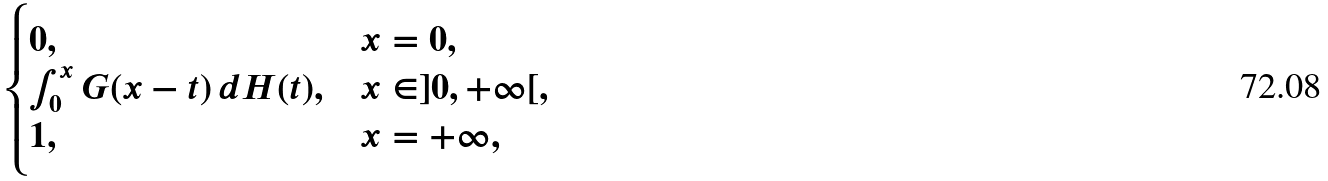<formula> <loc_0><loc_0><loc_500><loc_500>\begin{cases} 0 , & x = 0 , \\ \int _ { 0 } ^ { x } G ( x - t ) \, d H ( t ) , & x \in ] 0 , + \infty [ , \\ 1 , & x = + \infty , \end{cases}</formula> 